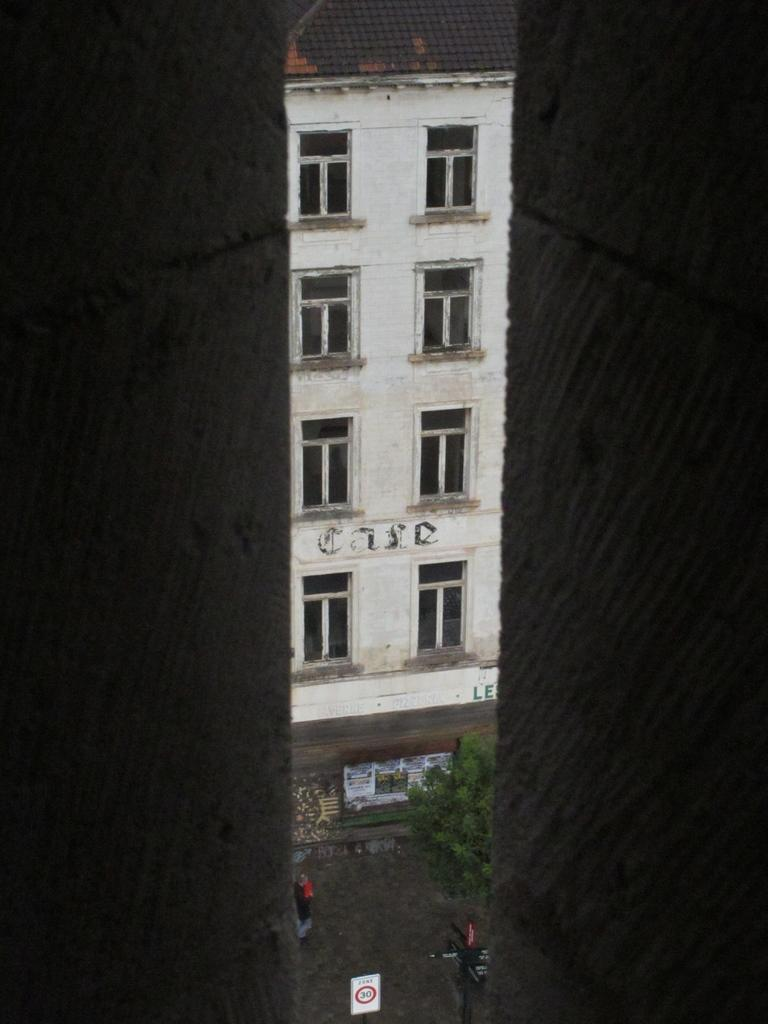How many walls are present in the image? There are two walls in the image. What is located between the walls? There is a building with windows between the walls. Can you describe the person visible in the image? A person is visible at the bottom of the image. What type of vegetation can be seen in the image? There are trees in the image. What additional feature is present in the image? There is a sign board in the image. What type of adjustment is the scarecrow making in the image? There is no scarecrow present in the image. What cause led to the formation of the building in the image? The provided facts do not mention the cause for the formation of the building; we can only describe its presence and location. 